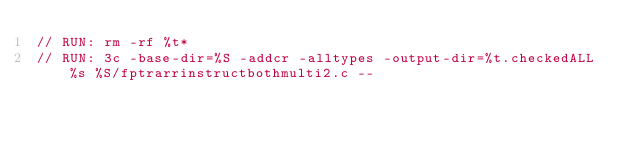<code> <loc_0><loc_0><loc_500><loc_500><_C_>// RUN: rm -rf %t*
// RUN: 3c -base-dir=%S -addcr -alltypes -output-dir=%t.checkedALL %s %S/fptrarrinstructbothmulti2.c --</code> 